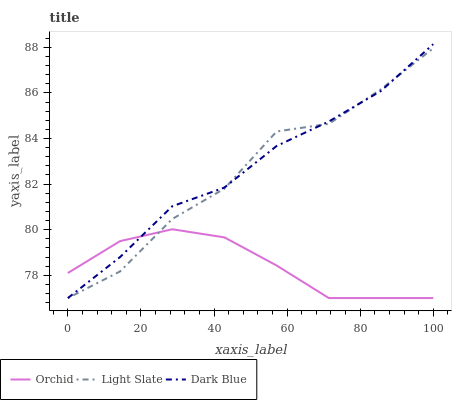Does Orchid have the minimum area under the curve?
Answer yes or no. Yes. Does Dark Blue have the maximum area under the curve?
Answer yes or no. Yes. Does Dark Blue have the minimum area under the curve?
Answer yes or no. No. Does Orchid have the maximum area under the curve?
Answer yes or no. No. Is Orchid the smoothest?
Answer yes or no. Yes. Is Light Slate the roughest?
Answer yes or no. Yes. Is Dark Blue the smoothest?
Answer yes or no. No. Is Dark Blue the roughest?
Answer yes or no. No. Does Dark Blue have the highest value?
Answer yes or no. Yes. Does Orchid have the highest value?
Answer yes or no. No. Does Dark Blue intersect Orchid?
Answer yes or no. Yes. Is Dark Blue less than Orchid?
Answer yes or no. No. Is Dark Blue greater than Orchid?
Answer yes or no. No. 